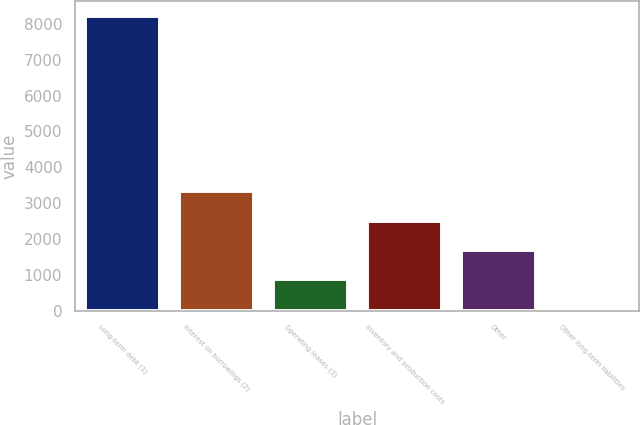Convert chart to OTSL. <chart><loc_0><loc_0><loc_500><loc_500><bar_chart><fcel>Long-term debt (1)<fcel>Interest on borrowings (2)<fcel>Operating leases (3)<fcel>Inventory and production costs<fcel>Other<fcel>Other long-term liabilities<nl><fcel>8221<fcel>3324.4<fcel>876.1<fcel>2508.3<fcel>1692.2<fcel>60<nl></chart> 